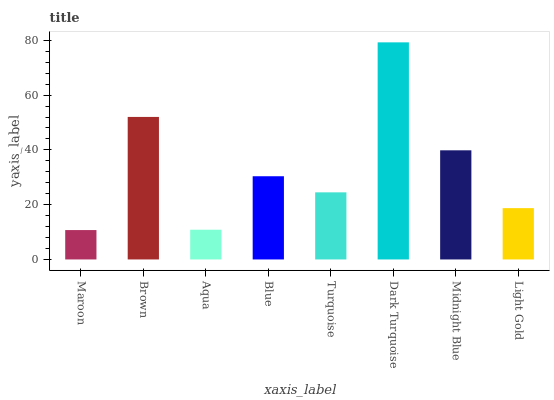Is Maroon the minimum?
Answer yes or no. Yes. Is Dark Turquoise the maximum?
Answer yes or no. Yes. Is Brown the minimum?
Answer yes or no. No. Is Brown the maximum?
Answer yes or no. No. Is Brown greater than Maroon?
Answer yes or no. Yes. Is Maroon less than Brown?
Answer yes or no. Yes. Is Maroon greater than Brown?
Answer yes or no. No. Is Brown less than Maroon?
Answer yes or no. No. Is Blue the high median?
Answer yes or no. Yes. Is Turquoise the low median?
Answer yes or no. Yes. Is Dark Turquoise the high median?
Answer yes or no. No. Is Blue the low median?
Answer yes or no. No. 